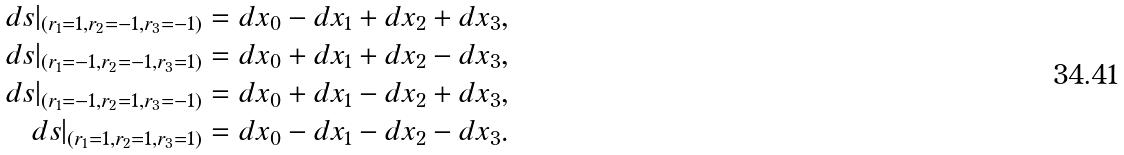Convert formula to latex. <formula><loc_0><loc_0><loc_500><loc_500>d s | _ { ( r _ { 1 } = 1 , r _ { 2 } = - 1 , r _ { 3 } = - 1 ) } = d x _ { 0 } - d x _ { 1 } + d x _ { 2 } + d x _ { 3 } , \\ d s | _ { ( r _ { 1 } = - 1 , r _ { 2 } = - 1 , r _ { 3 } = 1 ) } = d x _ { 0 } + d x _ { 1 } + d x _ { 2 } - d x _ { 3 } , \\ d s | _ { ( r _ { 1 } = - 1 , r _ { 2 } = 1 , r _ { 3 } = - 1 ) } = d x _ { 0 } + d x _ { 1 } - d x _ { 2 } + d x _ { 3 } , \\ d s | _ { ( r _ { 1 } = 1 , r _ { 2 } = 1 , r _ { 3 } = 1 ) } = d x _ { 0 } - d x _ { 1 } - d x _ { 2 } - d x _ { 3 } .</formula> 